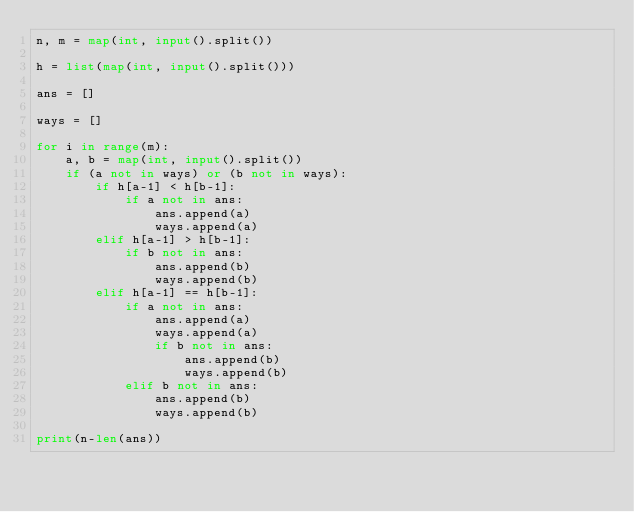<code> <loc_0><loc_0><loc_500><loc_500><_Python_>n, m = map(int, input().split())

h = list(map(int, input().split()))

ans = []

ways = []

for i in range(m):
    a, b = map(int, input().split())
    if (a not in ways) or (b not in ways):
        if h[a-1] < h[b-1]:
            if a not in ans:
                ans.append(a)
                ways.append(a)
        elif h[a-1] > h[b-1]:
            if b not in ans:
                ans.append(b)
                ways.append(b)
        elif h[a-1] == h[b-1]:
            if a not in ans:
                ans.append(a)
                ways.append(a)
                if b not in ans:
                    ans.append(b)
                    ways.append(b)
            elif b not in ans:
                ans.append(b)
                ways.append(b)

print(n-len(ans))
</code> 